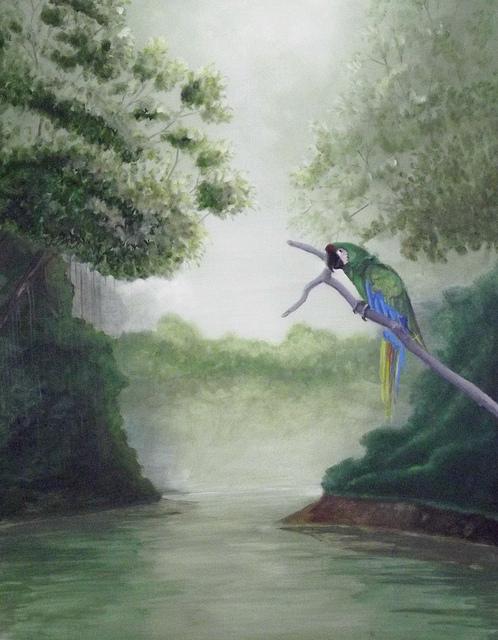Is the subject of this painting a person?
Write a very short answer. No. Is the artist of this painting famous?
Write a very short answer. No. What type of bird is this?
Give a very brief answer. Parrot. 